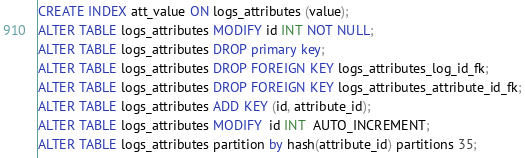<code> <loc_0><loc_0><loc_500><loc_500><_SQL_>CREATE INDEX att_value ON logs_attributes (value);
ALTER TABLE logs_attributes MODIFY id INT NOT NULL;
ALTER TABLE logs_attributes DROP primary key;
ALTER TABLE logs_attributes DROP FOREIGN KEY logs_attributes_log_id_fk;
ALTER TABLE logs_attributes DROP FOREIGN KEY logs_attributes_attribute_id_fk;
ALTER TABLE logs_attributes ADD KEY (id, attribute_id);
ALTER TABLE logs_attributes MODIFY  id INT  AUTO_INCREMENT;
ALTER TABLE logs_attributes partition by hash(attribute_id) partitions 35;</code> 